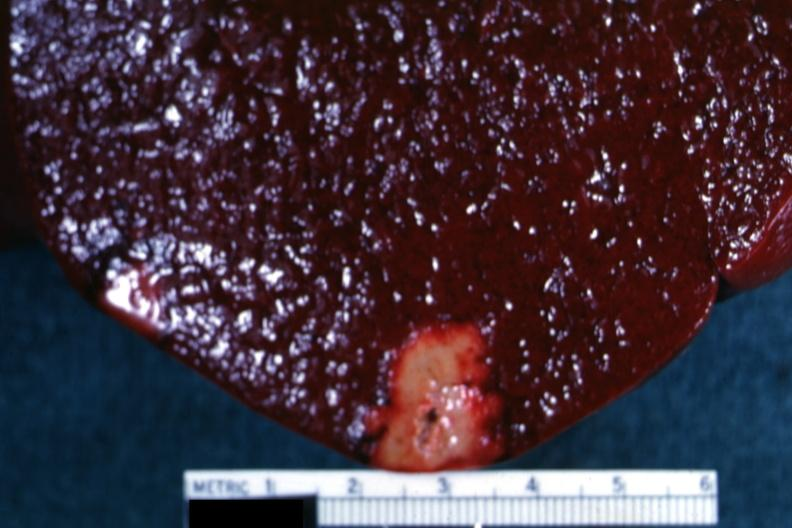does close-up tumor show yellow infarct with band of reactive hyperemia?
Answer the question using a single word or phrase. No 